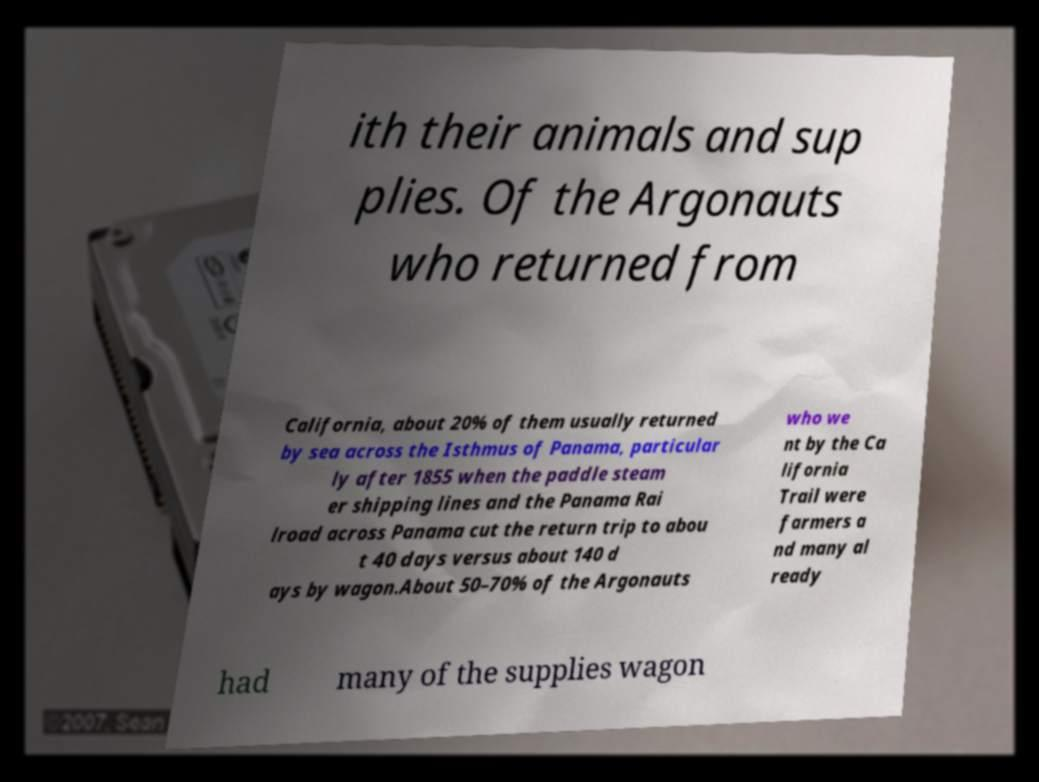I need the written content from this picture converted into text. Can you do that? ith their animals and sup plies. Of the Argonauts who returned from California, about 20% of them usually returned by sea across the Isthmus of Panama, particular ly after 1855 when the paddle steam er shipping lines and the Panama Rai lroad across Panama cut the return trip to abou t 40 days versus about 140 d ays by wagon.About 50–70% of the Argonauts who we nt by the Ca lifornia Trail were farmers a nd many al ready had many of the supplies wagon 